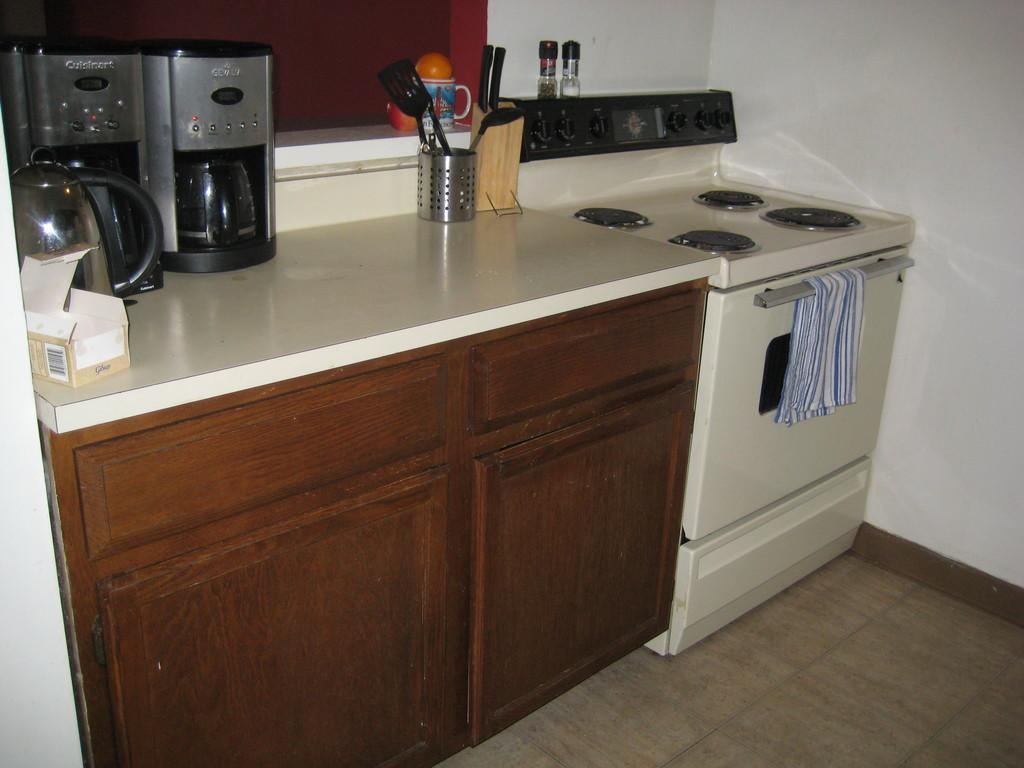What appliance is located on the countertop in the image? There is a machine on the countertop in the image. What other appliance can be seen on the countertop? There is a kettle on the countertop. What object on the countertop might contain items? There is a box on the countertop. What object on the countertop might be used for drinking? There is a cup on the countertop. What other appliances are near the countertop? There is a stove and an oven beside the countertop. What does your brother think about the company's credit policy? There is no mention of a brother, credit policy, or company in the image, so this question cannot be answered based on the provided facts. 